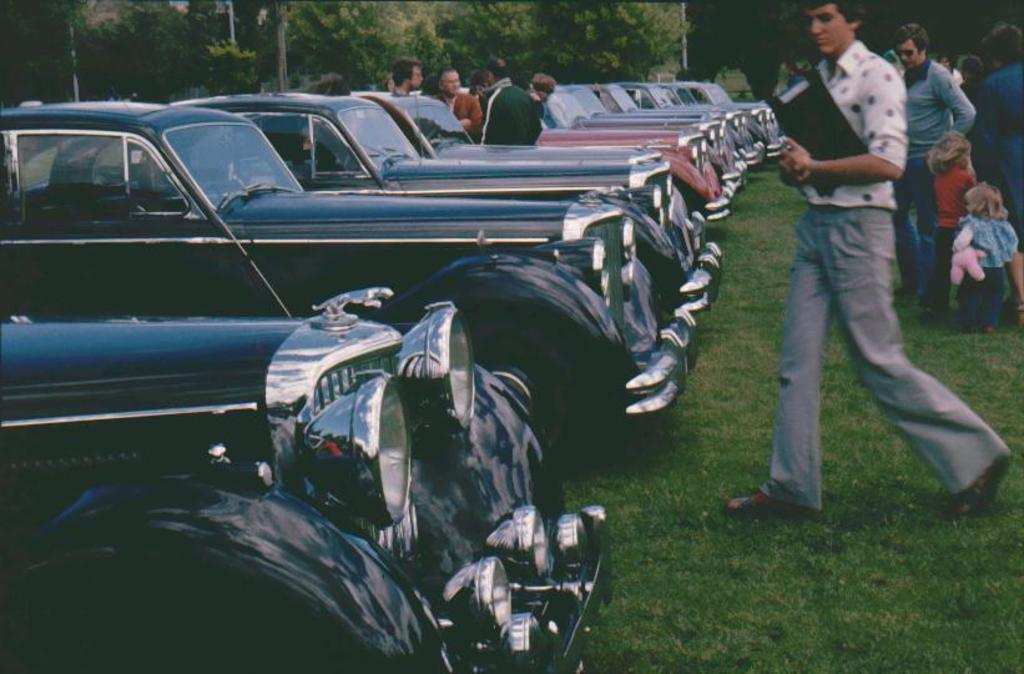What can be seen in the foreground of the image? There are fleets of cars and a crowd in the foreground of the image. What is visible in the background of the image? There are trees and poles in the background of the image. How was the image taken? The image was taken on the ground. What is the profit margin of the sweater being sold in the image? There is no sweater being sold in the image, so it is not possible to determine the profit margin. 